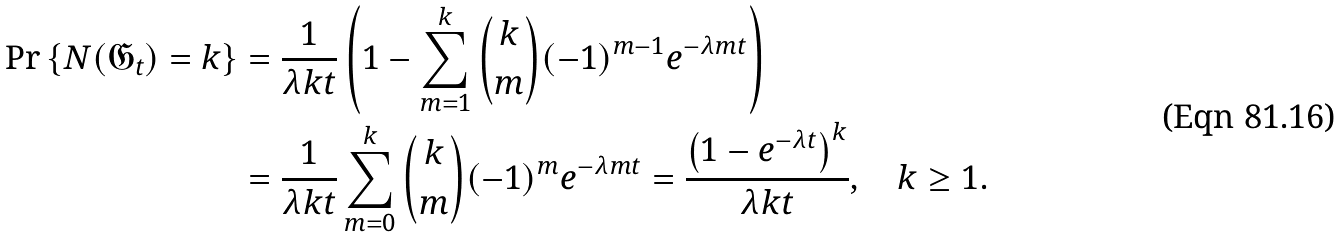<formula> <loc_0><loc_0><loc_500><loc_500>\text {Pr} \left \{ N ( \mathfrak { G } _ { t } ) = k \right \} & = \frac { 1 } { \lambda k t } \left ( 1 - \sum _ { m = 1 } ^ { k } \binom { k } { m } ( - 1 ) ^ { m - 1 } e ^ { - \lambda m t } \right ) \\ & = \frac { 1 } { \lambda k t } \sum _ { m = 0 } ^ { k } \binom { k } { m } ( - 1 ) ^ { m } e ^ { - \lambda m t } = \frac { \left ( 1 - e ^ { - \lambda t } \right ) ^ { k } } { \lambda k t } , \quad k \geq 1 .</formula> 